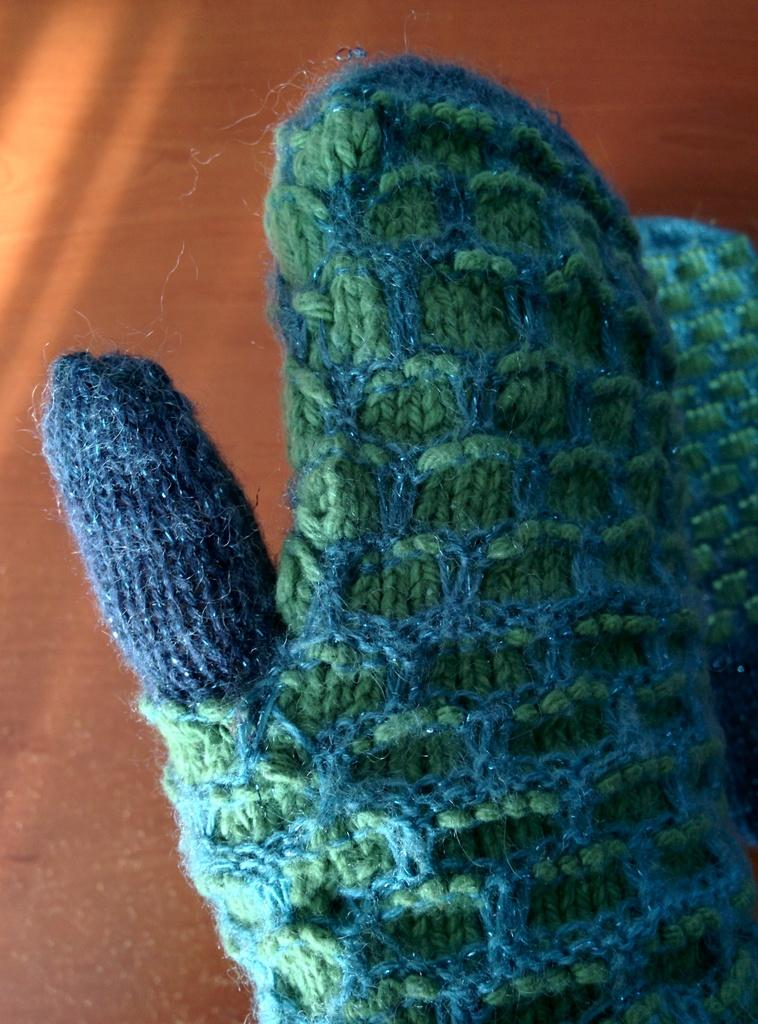What type of material is the cloth in the image made of? The cloth in the image is made of wool. Where is the woolen cloth located in the image? The woolen cloth is placed on a platform. What shape is the nerve that is visible in the image? There is no nerve visible in the image; it only features a woolen cloth placed on a platform. 